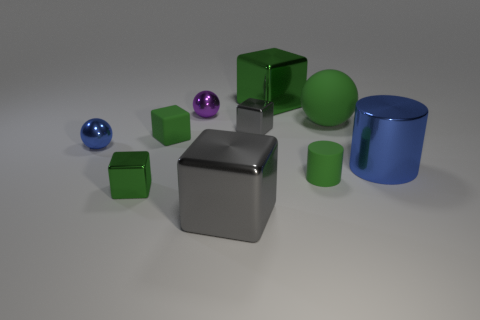What can you infer about the texture of the objects? The objects in the image appear to have a smooth, almost reflective surface texture. This suggests they might be made of a material like plastic or polished metal. 